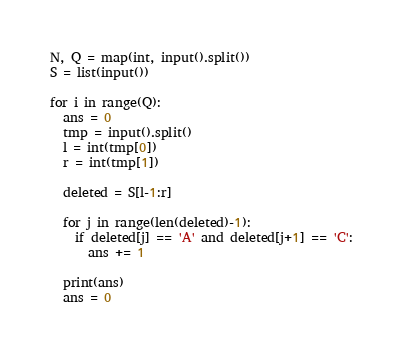<code> <loc_0><loc_0><loc_500><loc_500><_Python_>N, Q = map(int, input().split())
S = list(input())

for i in range(Q):
  ans = 0
  tmp = input().split()
  l = int(tmp[0])
  r = int(tmp[1])
  
  deleted = S[l-1:r]

  for j in range(len(deleted)-1):  
    if deleted[j] == 'A' and deleted[j+1] == 'C':
      ans += 1
  
  print(ans)
  ans = 0</code> 